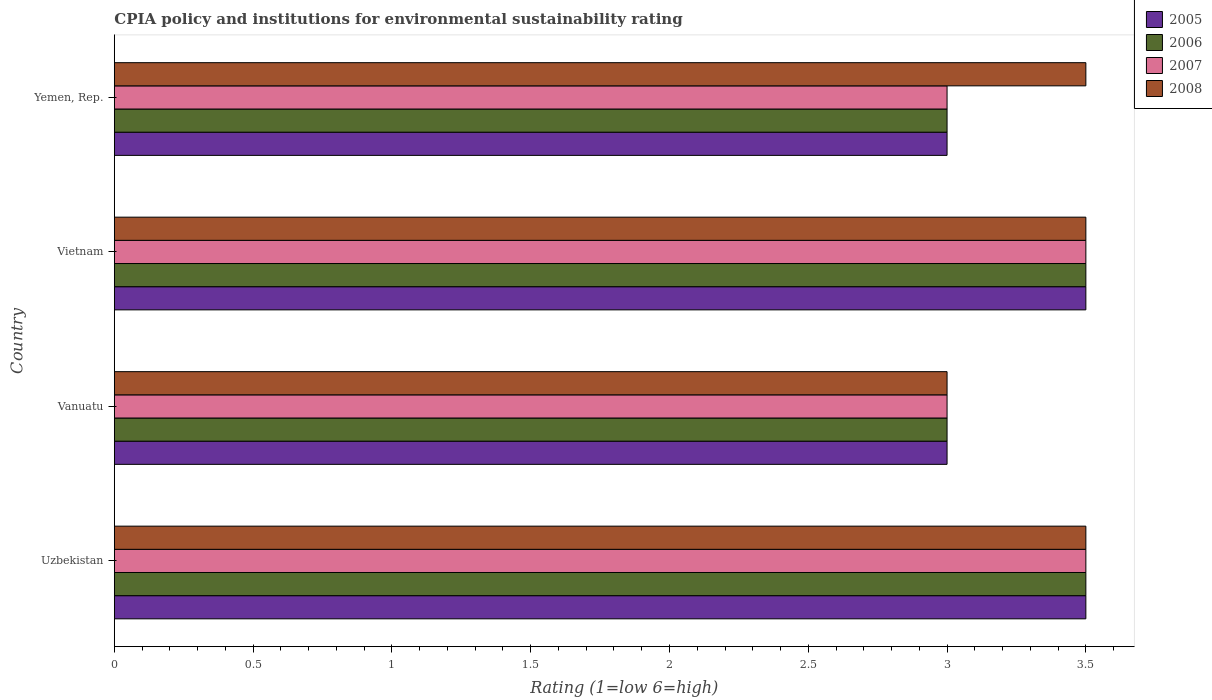How many different coloured bars are there?
Your answer should be compact. 4. How many groups of bars are there?
Offer a very short reply. 4. How many bars are there on the 2nd tick from the top?
Keep it short and to the point. 4. How many bars are there on the 4th tick from the bottom?
Offer a terse response. 4. What is the label of the 4th group of bars from the top?
Make the answer very short. Uzbekistan. What is the CPIA rating in 2006 in Yemen, Rep.?
Your answer should be compact. 3. Across all countries, what is the maximum CPIA rating in 2006?
Ensure brevity in your answer.  3.5. In which country was the CPIA rating in 2005 maximum?
Your response must be concise. Uzbekistan. In which country was the CPIA rating in 2007 minimum?
Your answer should be compact. Vanuatu. What is the total CPIA rating in 2006 in the graph?
Make the answer very short. 13. What is the difference between the CPIA rating in 2008 in Vietnam and that in Yemen, Rep.?
Provide a short and direct response. 0. What is the difference between the CPIA rating in 2008 and CPIA rating in 2005 in Vietnam?
Offer a very short reply. 0. In how many countries, is the CPIA rating in 2006 greater than 2.9 ?
Your answer should be compact. 4. What is the ratio of the CPIA rating in 2005 in Uzbekistan to that in Vietnam?
Give a very brief answer. 1. Is the CPIA rating in 2006 in Uzbekistan less than that in Vietnam?
Your answer should be compact. No. Is the difference between the CPIA rating in 2008 in Vanuatu and Vietnam greater than the difference between the CPIA rating in 2005 in Vanuatu and Vietnam?
Your response must be concise. No. What is the difference between the highest and the second highest CPIA rating in 2005?
Provide a short and direct response. 0. In how many countries, is the CPIA rating in 2006 greater than the average CPIA rating in 2006 taken over all countries?
Keep it short and to the point. 2. Is the sum of the CPIA rating in 2007 in Vanuatu and Vietnam greater than the maximum CPIA rating in 2005 across all countries?
Keep it short and to the point. Yes. Is it the case that in every country, the sum of the CPIA rating in 2006 and CPIA rating in 2008 is greater than the sum of CPIA rating in 2007 and CPIA rating in 2005?
Provide a succinct answer. No. What does the 3rd bar from the top in Yemen, Rep. represents?
Give a very brief answer. 2006. How many bars are there?
Keep it short and to the point. 16. Are all the bars in the graph horizontal?
Your response must be concise. Yes. Are the values on the major ticks of X-axis written in scientific E-notation?
Your response must be concise. No. Does the graph contain any zero values?
Make the answer very short. No. Does the graph contain grids?
Your answer should be very brief. No. Where does the legend appear in the graph?
Provide a succinct answer. Top right. How many legend labels are there?
Provide a short and direct response. 4. What is the title of the graph?
Provide a succinct answer. CPIA policy and institutions for environmental sustainability rating. Does "1979" appear as one of the legend labels in the graph?
Provide a succinct answer. No. What is the label or title of the Y-axis?
Give a very brief answer. Country. What is the Rating (1=low 6=high) of 2006 in Uzbekistan?
Offer a very short reply. 3.5. What is the Rating (1=low 6=high) of 2008 in Uzbekistan?
Provide a succinct answer. 3.5. What is the Rating (1=low 6=high) in 2008 in Vanuatu?
Ensure brevity in your answer.  3. What is the Rating (1=low 6=high) in 2005 in Vietnam?
Give a very brief answer. 3.5. What is the Rating (1=low 6=high) in 2006 in Vietnam?
Give a very brief answer. 3.5. What is the Rating (1=low 6=high) of 2008 in Vietnam?
Provide a short and direct response. 3.5. What is the Rating (1=low 6=high) in 2005 in Yemen, Rep.?
Keep it short and to the point. 3. What is the Rating (1=low 6=high) of 2006 in Yemen, Rep.?
Provide a succinct answer. 3. What is the Rating (1=low 6=high) in 2007 in Yemen, Rep.?
Keep it short and to the point. 3. What is the Rating (1=low 6=high) in 2008 in Yemen, Rep.?
Your response must be concise. 3.5. Across all countries, what is the maximum Rating (1=low 6=high) of 2007?
Provide a short and direct response. 3.5. Across all countries, what is the maximum Rating (1=low 6=high) in 2008?
Your answer should be very brief. 3.5. Across all countries, what is the minimum Rating (1=low 6=high) in 2006?
Offer a terse response. 3. What is the total Rating (1=low 6=high) in 2005 in the graph?
Make the answer very short. 13. What is the total Rating (1=low 6=high) of 2007 in the graph?
Your answer should be compact. 13. What is the total Rating (1=low 6=high) in 2008 in the graph?
Your response must be concise. 13.5. What is the difference between the Rating (1=low 6=high) in 2005 in Uzbekistan and that in Vanuatu?
Make the answer very short. 0.5. What is the difference between the Rating (1=low 6=high) of 2006 in Uzbekistan and that in Vanuatu?
Your response must be concise. 0.5. What is the difference between the Rating (1=low 6=high) in 2008 in Uzbekistan and that in Vanuatu?
Keep it short and to the point. 0.5. What is the difference between the Rating (1=low 6=high) of 2005 in Uzbekistan and that in Vietnam?
Offer a very short reply. 0. What is the difference between the Rating (1=low 6=high) in 2008 in Uzbekistan and that in Vietnam?
Provide a succinct answer. 0. What is the difference between the Rating (1=low 6=high) of 2008 in Uzbekistan and that in Yemen, Rep.?
Offer a terse response. 0. What is the difference between the Rating (1=low 6=high) in 2005 in Vanuatu and that in Vietnam?
Provide a short and direct response. -0.5. What is the difference between the Rating (1=low 6=high) in 2007 in Vanuatu and that in Vietnam?
Your answer should be very brief. -0.5. What is the difference between the Rating (1=low 6=high) in 2008 in Vanuatu and that in Vietnam?
Ensure brevity in your answer.  -0.5. What is the difference between the Rating (1=low 6=high) of 2005 in Vanuatu and that in Yemen, Rep.?
Offer a terse response. 0. What is the difference between the Rating (1=low 6=high) in 2006 in Vanuatu and that in Yemen, Rep.?
Offer a very short reply. 0. What is the difference between the Rating (1=low 6=high) of 2007 in Vanuatu and that in Yemen, Rep.?
Keep it short and to the point. 0. What is the difference between the Rating (1=low 6=high) in 2006 in Vietnam and that in Yemen, Rep.?
Keep it short and to the point. 0.5. What is the difference between the Rating (1=low 6=high) in 2007 in Vietnam and that in Yemen, Rep.?
Give a very brief answer. 0.5. What is the difference between the Rating (1=low 6=high) of 2008 in Vietnam and that in Yemen, Rep.?
Ensure brevity in your answer.  0. What is the difference between the Rating (1=low 6=high) of 2005 in Uzbekistan and the Rating (1=low 6=high) of 2006 in Vanuatu?
Your answer should be compact. 0.5. What is the difference between the Rating (1=low 6=high) of 2005 in Uzbekistan and the Rating (1=low 6=high) of 2007 in Vanuatu?
Your answer should be compact. 0.5. What is the difference between the Rating (1=low 6=high) of 2006 in Uzbekistan and the Rating (1=low 6=high) of 2007 in Vanuatu?
Provide a succinct answer. 0.5. What is the difference between the Rating (1=low 6=high) of 2007 in Uzbekistan and the Rating (1=low 6=high) of 2008 in Vanuatu?
Your response must be concise. 0.5. What is the difference between the Rating (1=low 6=high) in 2005 in Uzbekistan and the Rating (1=low 6=high) in 2007 in Vietnam?
Your response must be concise. 0. What is the difference between the Rating (1=low 6=high) in 2006 in Uzbekistan and the Rating (1=low 6=high) in 2008 in Vietnam?
Ensure brevity in your answer.  0. What is the difference between the Rating (1=low 6=high) of 2005 in Uzbekistan and the Rating (1=low 6=high) of 2007 in Yemen, Rep.?
Your answer should be very brief. 0.5. What is the difference between the Rating (1=low 6=high) in 2005 in Uzbekistan and the Rating (1=low 6=high) in 2008 in Yemen, Rep.?
Ensure brevity in your answer.  0. What is the difference between the Rating (1=low 6=high) in 2006 in Uzbekistan and the Rating (1=low 6=high) in 2007 in Yemen, Rep.?
Ensure brevity in your answer.  0.5. What is the difference between the Rating (1=low 6=high) in 2007 in Uzbekistan and the Rating (1=low 6=high) in 2008 in Yemen, Rep.?
Provide a succinct answer. 0. What is the difference between the Rating (1=low 6=high) in 2006 in Vanuatu and the Rating (1=low 6=high) in 2008 in Vietnam?
Offer a very short reply. -0.5. What is the difference between the Rating (1=low 6=high) in 2005 in Vanuatu and the Rating (1=low 6=high) in 2007 in Yemen, Rep.?
Your response must be concise. 0. What is the difference between the Rating (1=low 6=high) of 2006 in Vanuatu and the Rating (1=low 6=high) of 2007 in Yemen, Rep.?
Offer a terse response. 0. What is the difference between the Rating (1=low 6=high) in 2006 in Vanuatu and the Rating (1=low 6=high) in 2008 in Yemen, Rep.?
Provide a short and direct response. -0.5. What is the difference between the Rating (1=low 6=high) of 2005 in Vietnam and the Rating (1=low 6=high) of 2007 in Yemen, Rep.?
Make the answer very short. 0.5. What is the difference between the Rating (1=low 6=high) of 2005 in Vietnam and the Rating (1=low 6=high) of 2008 in Yemen, Rep.?
Ensure brevity in your answer.  0. What is the difference between the Rating (1=low 6=high) in 2006 in Vietnam and the Rating (1=low 6=high) in 2008 in Yemen, Rep.?
Your response must be concise. 0. What is the average Rating (1=low 6=high) in 2005 per country?
Offer a terse response. 3.25. What is the average Rating (1=low 6=high) in 2007 per country?
Keep it short and to the point. 3.25. What is the average Rating (1=low 6=high) of 2008 per country?
Offer a terse response. 3.38. What is the difference between the Rating (1=low 6=high) of 2005 and Rating (1=low 6=high) of 2007 in Uzbekistan?
Offer a very short reply. 0. What is the difference between the Rating (1=low 6=high) in 2005 and Rating (1=low 6=high) in 2008 in Uzbekistan?
Give a very brief answer. 0. What is the difference between the Rating (1=low 6=high) of 2006 and Rating (1=low 6=high) of 2007 in Uzbekistan?
Offer a terse response. 0. What is the difference between the Rating (1=low 6=high) in 2006 and Rating (1=low 6=high) in 2008 in Uzbekistan?
Give a very brief answer. 0. What is the difference between the Rating (1=low 6=high) of 2007 and Rating (1=low 6=high) of 2008 in Uzbekistan?
Provide a short and direct response. 0. What is the difference between the Rating (1=low 6=high) of 2005 and Rating (1=low 6=high) of 2008 in Vanuatu?
Keep it short and to the point. 0. What is the difference between the Rating (1=low 6=high) of 2007 and Rating (1=low 6=high) of 2008 in Vanuatu?
Your answer should be very brief. 0. What is the difference between the Rating (1=low 6=high) of 2005 and Rating (1=low 6=high) of 2006 in Vietnam?
Offer a very short reply. 0. What is the difference between the Rating (1=low 6=high) in 2005 and Rating (1=low 6=high) in 2008 in Vietnam?
Offer a terse response. 0. What is the difference between the Rating (1=low 6=high) of 2006 and Rating (1=low 6=high) of 2007 in Vietnam?
Make the answer very short. 0. What is the difference between the Rating (1=low 6=high) of 2006 and Rating (1=low 6=high) of 2008 in Vietnam?
Offer a terse response. 0. What is the difference between the Rating (1=low 6=high) in 2005 and Rating (1=low 6=high) in 2007 in Yemen, Rep.?
Make the answer very short. 0. What is the difference between the Rating (1=low 6=high) of 2006 and Rating (1=low 6=high) of 2008 in Yemen, Rep.?
Your answer should be very brief. -0.5. What is the difference between the Rating (1=low 6=high) of 2007 and Rating (1=low 6=high) of 2008 in Yemen, Rep.?
Keep it short and to the point. -0.5. What is the ratio of the Rating (1=low 6=high) of 2005 in Uzbekistan to that in Vanuatu?
Your answer should be compact. 1.17. What is the ratio of the Rating (1=low 6=high) in 2008 in Uzbekistan to that in Vanuatu?
Make the answer very short. 1.17. What is the ratio of the Rating (1=low 6=high) in 2005 in Uzbekistan to that in Vietnam?
Offer a terse response. 1. What is the ratio of the Rating (1=low 6=high) of 2007 in Uzbekistan to that in Vietnam?
Ensure brevity in your answer.  1. What is the ratio of the Rating (1=low 6=high) in 2008 in Uzbekistan to that in Vietnam?
Give a very brief answer. 1. What is the ratio of the Rating (1=low 6=high) in 2008 in Uzbekistan to that in Yemen, Rep.?
Your answer should be compact. 1. What is the ratio of the Rating (1=low 6=high) in 2005 in Vanuatu to that in Vietnam?
Make the answer very short. 0.86. What is the ratio of the Rating (1=low 6=high) in 2006 in Vanuatu to that in Vietnam?
Your response must be concise. 0.86. What is the ratio of the Rating (1=low 6=high) of 2008 in Vanuatu to that in Vietnam?
Make the answer very short. 0.86. What is the ratio of the Rating (1=low 6=high) in 2008 in Vanuatu to that in Yemen, Rep.?
Provide a succinct answer. 0.86. What is the ratio of the Rating (1=low 6=high) in 2005 in Vietnam to that in Yemen, Rep.?
Keep it short and to the point. 1.17. What is the ratio of the Rating (1=low 6=high) in 2006 in Vietnam to that in Yemen, Rep.?
Provide a succinct answer. 1.17. What is the ratio of the Rating (1=low 6=high) in 2008 in Vietnam to that in Yemen, Rep.?
Provide a succinct answer. 1. What is the difference between the highest and the second highest Rating (1=low 6=high) of 2007?
Offer a terse response. 0. What is the difference between the highest and the lowest Rating (1=low 6=high) of 2005?
Your answer should be very brief. 0.5. What is the difference between the highest and the lowest Rating (1=low 6=high) of 2006?
Provide a succinct answer. 0.5. What is the difference between the highest and the lowest Rating (1=low 6=high) of 2007?
Your response must be concise. 0.5. What is the difference between the highest and the lowest Rating (1=low 6=high) of 2008?
Give a very brief answer. 0.5. 